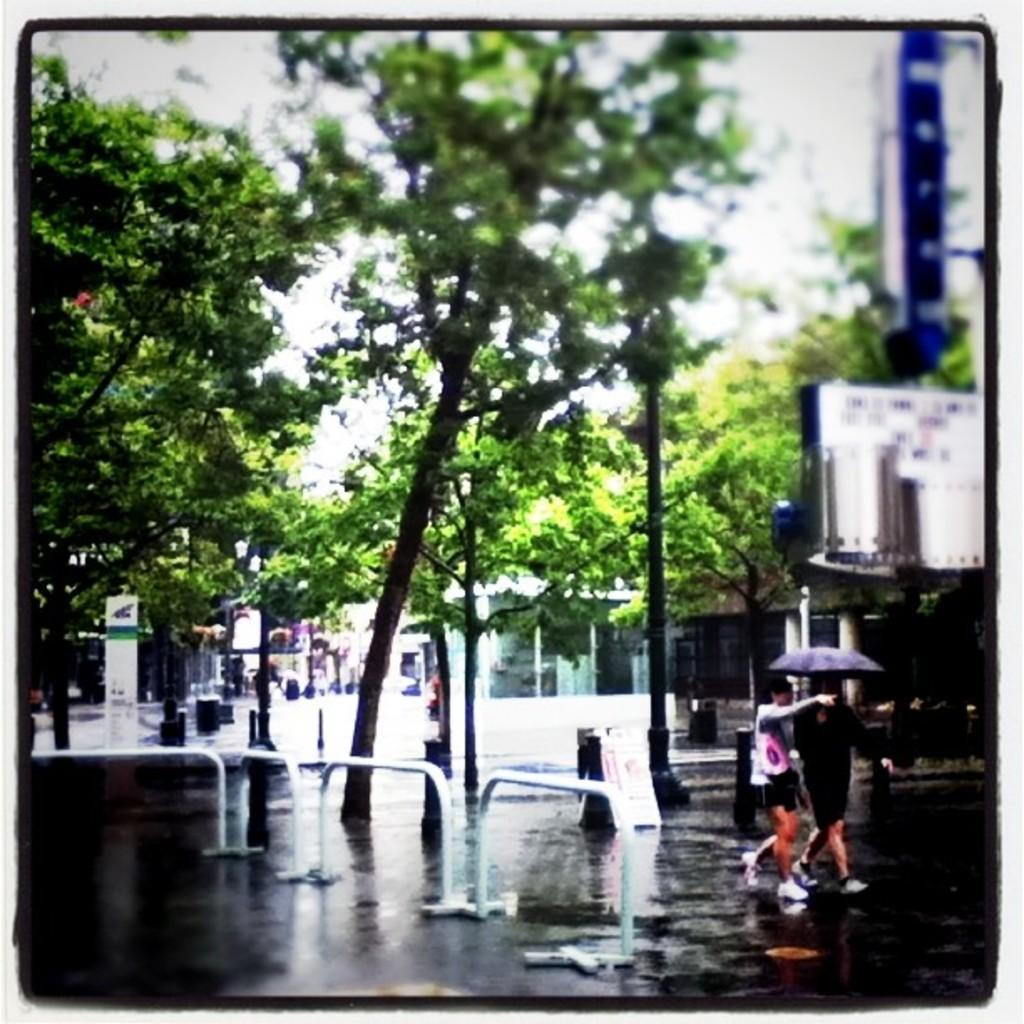What type of natural elements can be seen in the image? There are trees in the image. What type of man-made structures are present in the image? There are stores and advertisement boards visible in the image. What might be used to separate or guide traffic in the image? Barriers are visible in the image. What type of street furniture can be seen in the image? Street poles are in the image. What are the people in the image doing? The persons are walking on the road in the image, and they are holding umbrellas. What is visible in the sky in the image? The sky is visible in the image. How many cats are sitting on the line in the image? There are no cats or lines present in the image. What type of low-hanging fruit can be seen in the image? There is no fruit present in the image. 